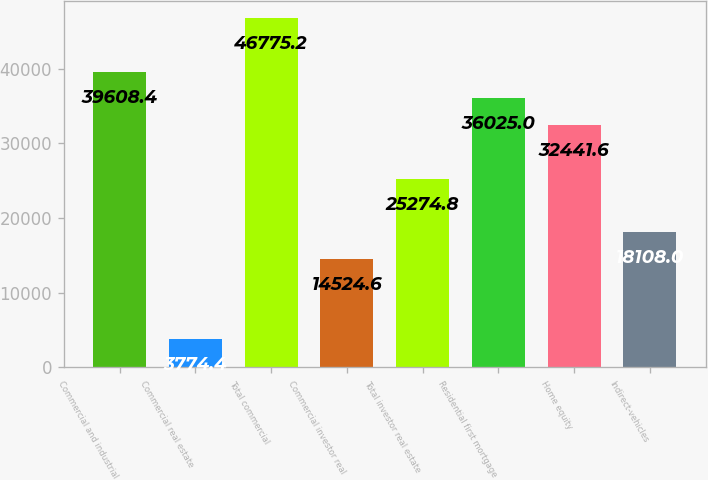<chart> <loc_0><loc_0><loc_500><loc_500><bar_chart><fcel>Commercial and industrial<fcel>Commercial real estate<fcel>Total commercial<fcel>Commercial investor real<fcel>Total investor real estate<fcel>Residential first mortgage<fcel>Home equity<fcel>Indirect-vehicles<nl><fcel>39608.4<fcel>3774.4<fcel>46775.2<fcel>14524.6<fcel>25274.8<fcel>36025<fcel>32441.6<fcel>18108<nl></chart> 